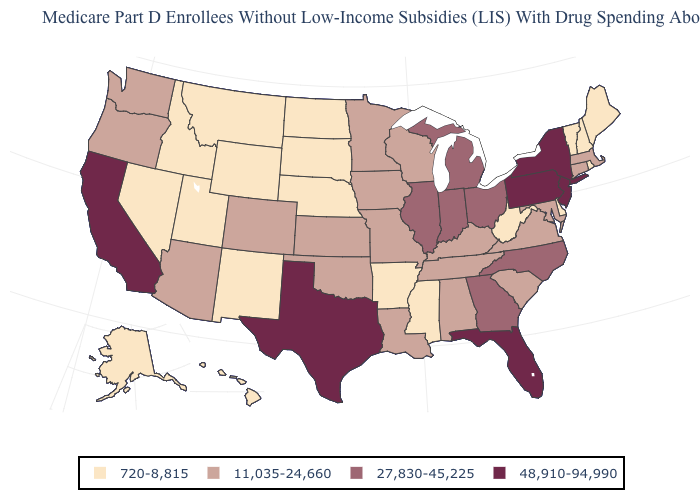Does the first symbol in the legend represent the smallest category?
Give a very brief answer. Yes. Among the states that border New York , which have the highest value?
Short answer required. New Jersey, Pennsylvania. Among the states that border Vermont , which have the highest value?
Short answer required. New York. What is the lowest value in the MidWest?
Give a very brief answer. 720-8,815. Which states have the lowest value in the USA?
Write a very short answer. Alaska, Arkansas, Delaware, Hawaii, Idaho, Maine, Mississippi, Montana, Nebraska, Nevada, New Hampshire, New Mexico, North Dakota, Rhode Island, South Dakota, Utah, Vermont, West Virginia, Wyoming. What is the value of North Dakota?
Write a very short answer. 720-8,815. Among the states that border South Dakota , which have the lowest value?
Concise answer only. Montana, Nebraska, North Dakota, Wyoming. What is the value of Idaho?
Keep it brief. 720-8,815. What is the value of Tennessee?
Short answer required. 11,035-24,660. Among the states that border Michigan , does Indiana have the highest value?
Concise answer only. Yes. Does Michigan have the same value as Georgia?
Quick response, please. Yes. Among the states that border Ohio , which have the lowest value?
Give a very brief answer. West Virginia. What is the value of Missouri?
Be succinct. 11,035-24,660. Name the states that have a value in the range 27,830-45,225?
Short answer required. Georgia, Illinois, Indiana, Michigan, North Carolina, Ohio. 